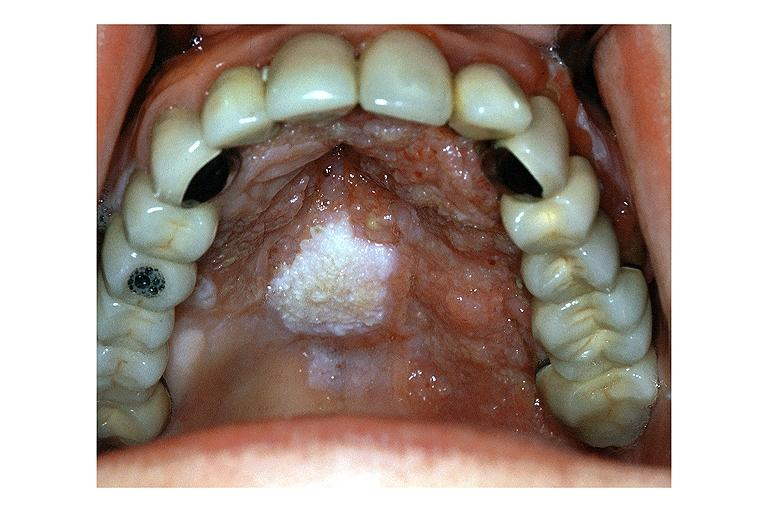what is present?
Answer the question using a single word or phrase. Oral 